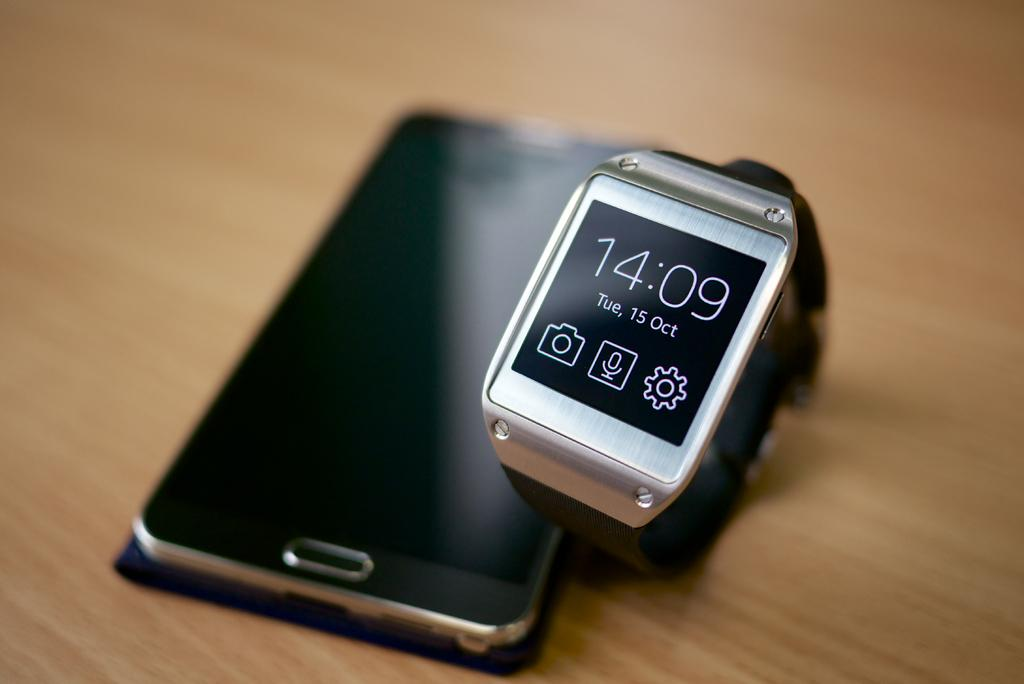<image>
Summarize the visual content of the image. A smart watch next to a smart phone the date is Tuesday October 15th and the time is 14:09. 